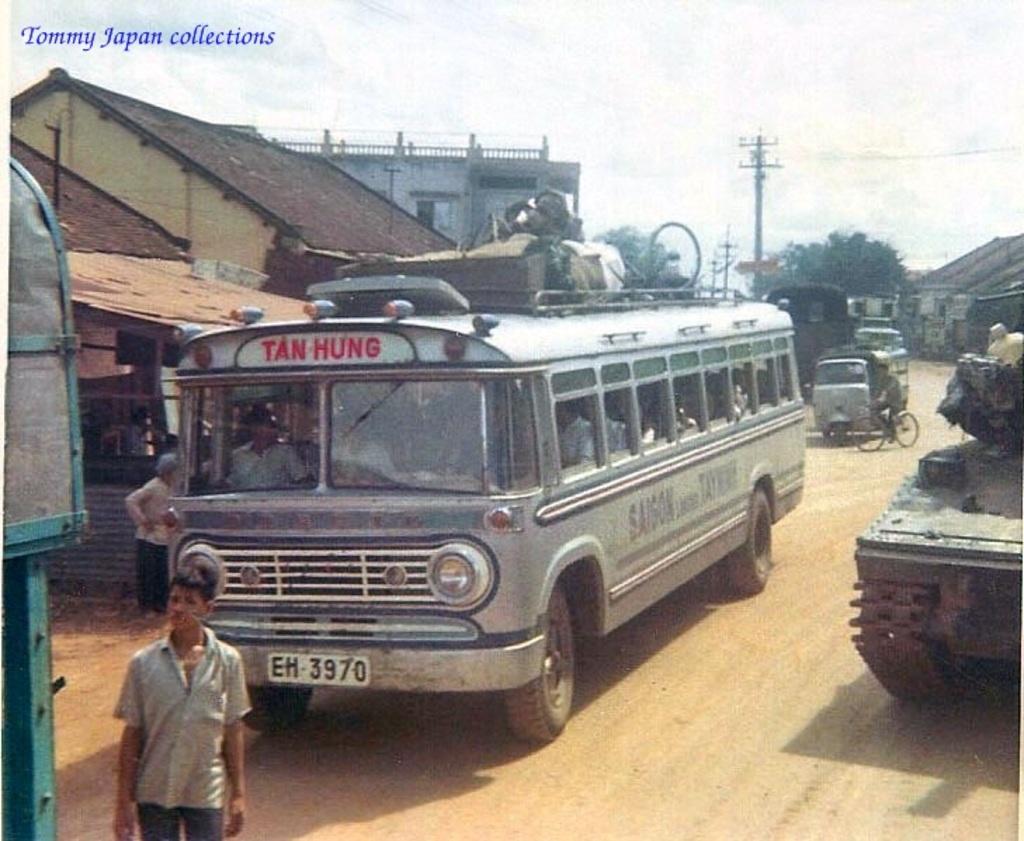What is the buses plate number?
Your response must be concise. Eh 3970. What does the top of the bus say?
Keep it short and to the point. Tan hung. 